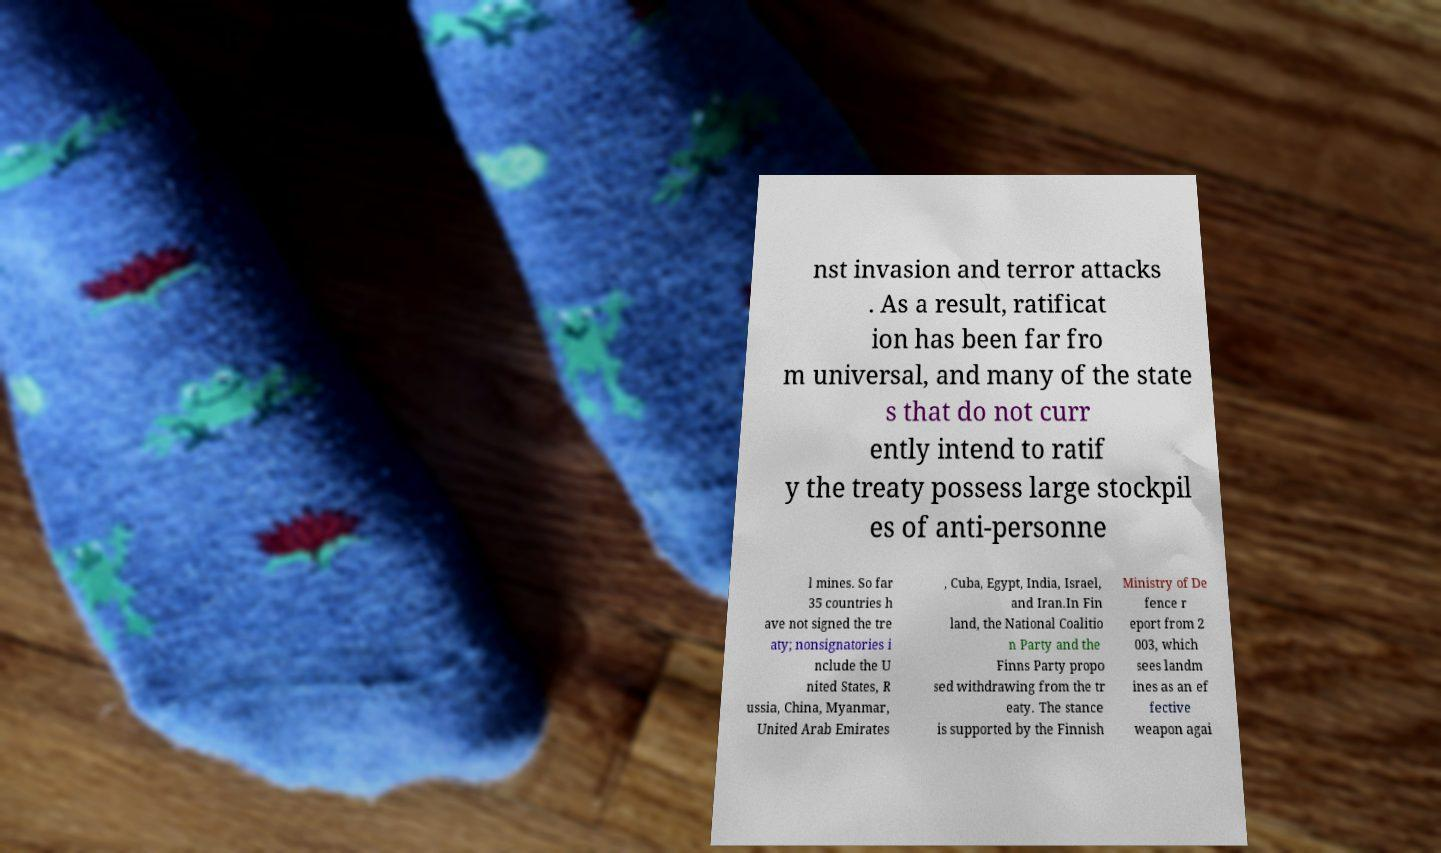I need the written content from this picture converted into text. Can you do that? nst invasion and terror attacks . As a result, ratificat ion has been far fro m universal, and many of the state s that do not curr ently intend to ratif y the treaty possess large stockpil es of anti-personne l mines. So far 35 countries h ave not signed the tre aty; nonsignatories i nclude the U nited States, R ussia, China, Myanmar, United Arab Emirates , Cuba, Egypt, India, Israel, and Iran.In Fin land, the National Coalitio n Party and the Finns Party propo sed withdrawing from the tr eaty. The stance is supported by the Finnish Ministry of De fence r eport from 2 003, which sees landm ines as an ef fective weapon agai 